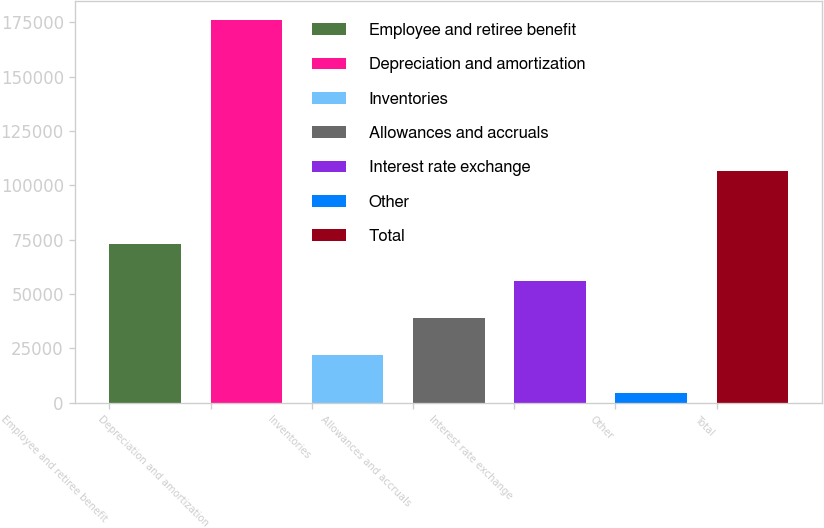Convert chart to OTSL. <chart><loc_0><loc_0><loc_500><loc_500><bar_chart><fcel>Employee and retiree benefit<fcel>Depreciation and amortization<fcel>Inventories<fcel>Allowances and accruals<fcel>Interest rate exchange<fcel>Other<fcel>Total<nl><fcel>73139.2<fcel>175894<fcel>21761.8<fcel>38887.6<fcel>56013.4<fcel>4636<fcel>106473<nl></chart> 